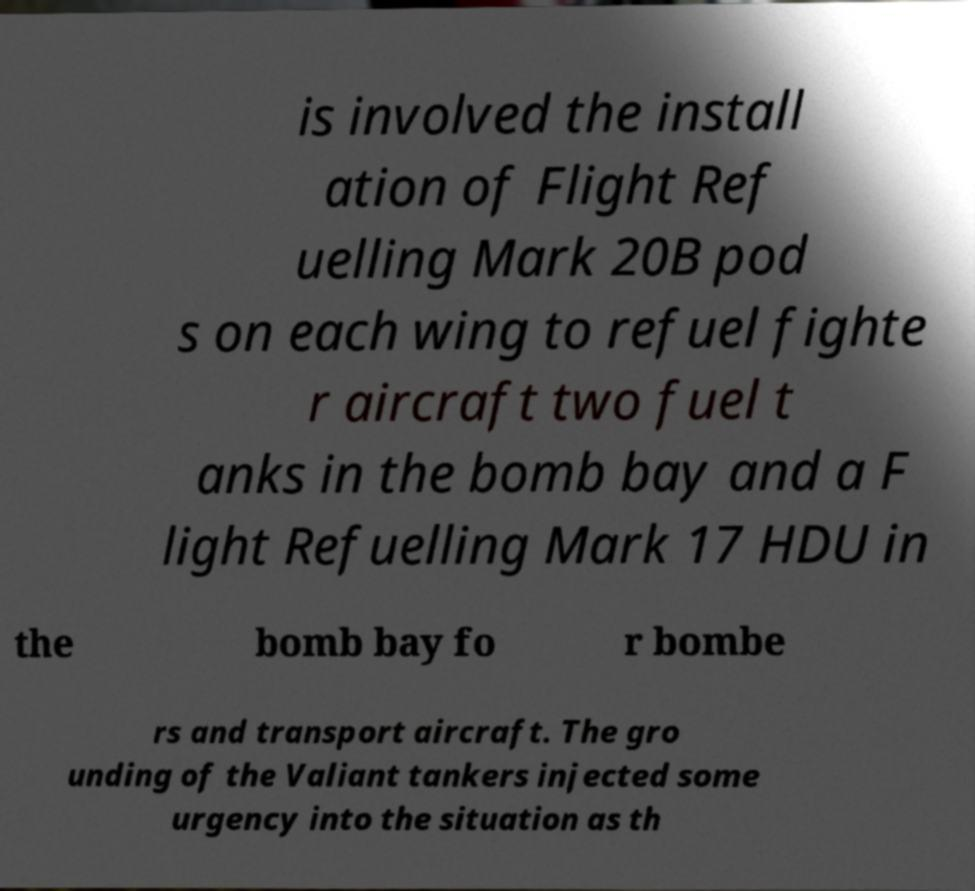Please read and relay the text visible in this image. What does it say? is involved the install ation of Flight Ref uelling Mark 20B pod s on each wing to refuel fighte r aircraft two fuel t anks in the bomb bay and a F light Refuelling Mark 17 HDU in the bomb bay fo r bombe rs and transport aircraft. The gro unding of the Valiant tankers injected some urgency into the situation as th 